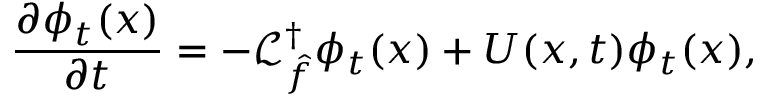Convert formula to latex. <formula><loc_0><loc_0><loc_500><loc_500>\frac { \partial \phi _ { t } ( x ) } { \partial t } = - \mathcal { L } _ { \hat { f } } ^ { \dagger } \phi _ { t } ( x ) + U ( x , t ) \phi _ { t } ( x ) ,</formula> 